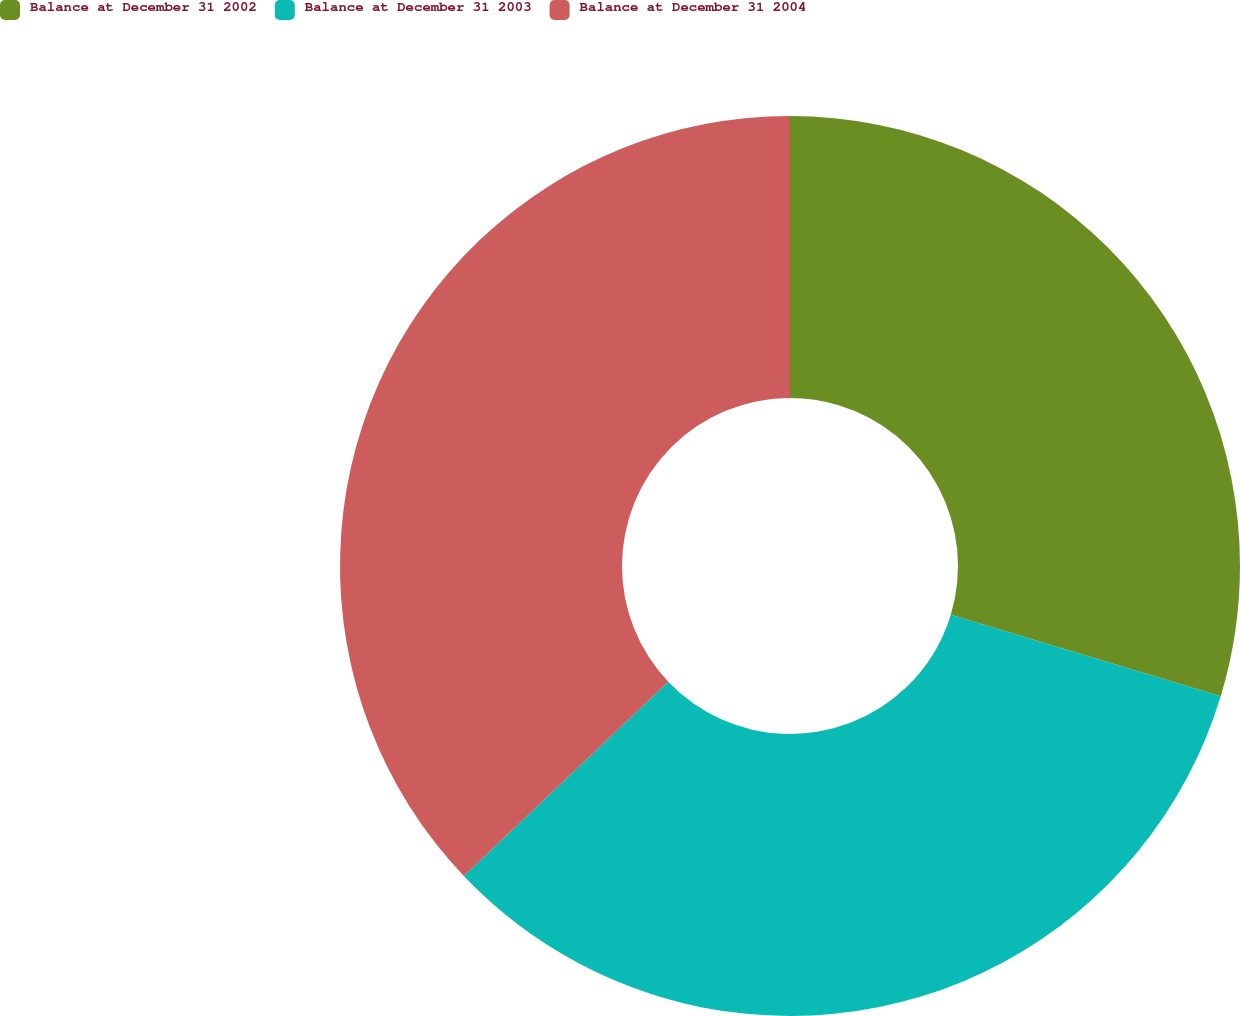<chart> <loc_0><loc_0><loc_500><loc_500><pie_chart><fcel>Balance at December 31 2002<fcel>Balance at December 31 2003<fcel>Balance at December 31 2004<nl><fcel>29.68%<fcel>33.23%<fcel>37.1%<nl></chart> 